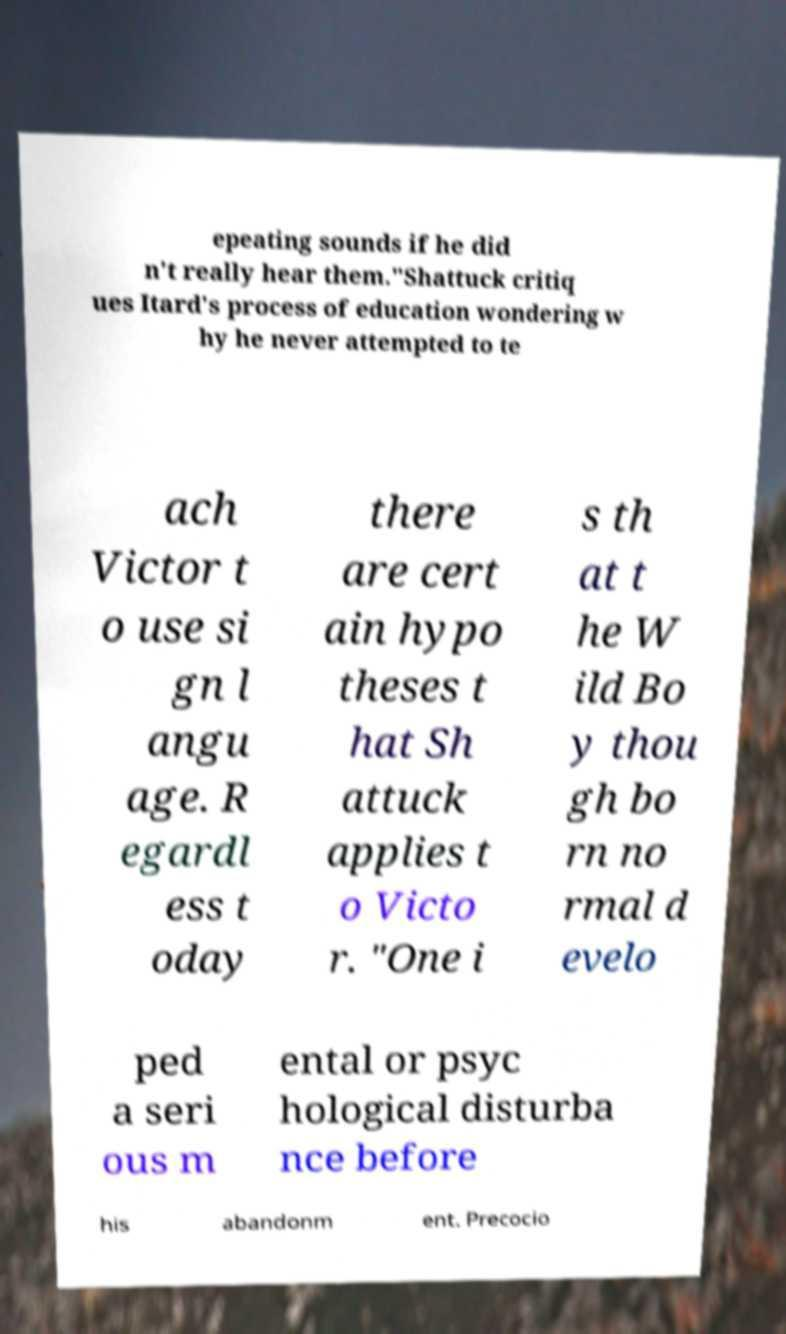Can you accurately transcribe the text from the provided image for me? epeating sounds if he did n't really hear them."Shattuck critiq ues Itard's process of education wondering w hy he never attempted to te ach Victor t o use si gn l angu age. R egardl ess t oday there are cert ain hypo theses t hat Sh attuck applies t o Victo r. "One i s th at t he W ild Bo y thou gh bo rn no rmal d evelo ped a seri ous m ental or psyc hological disturba nce before his abandonm ent. Precocio 